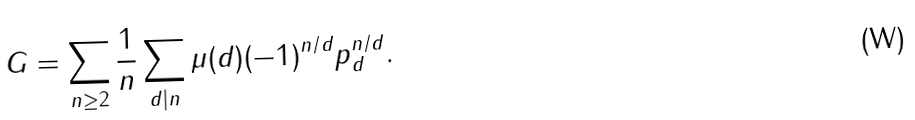<formula> <loc_0><loc_0><loc_500><loc_500>G = \sum _ { n \geq 2 } \frac { 1 } { n } \sum _ { d | n } \mu ( d ) ( - 1 ) ^ { n / d } p _ { d } ^ { n / d } .</formula> 